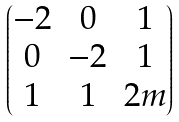<formula> <loc_0><loc_0><loc_500><loc_500>\begin{pmatrix} - 2 & 0 & 1 \\ 0 & - 2 & 1 \\ 1 & 1 & 2 m \end{pmatrix}</formula> 